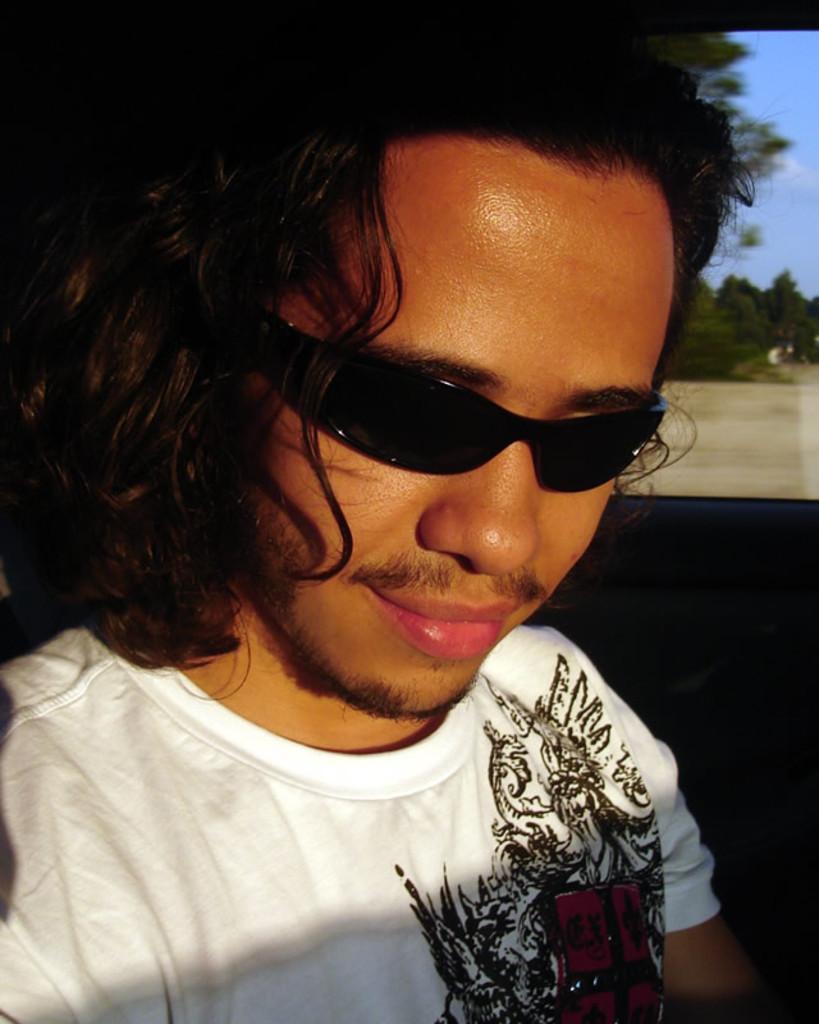Could you give a brief overview of what you see in this image? In this image we can see a man smiling. He is wearing glasses. In the background there are trees and sky. 